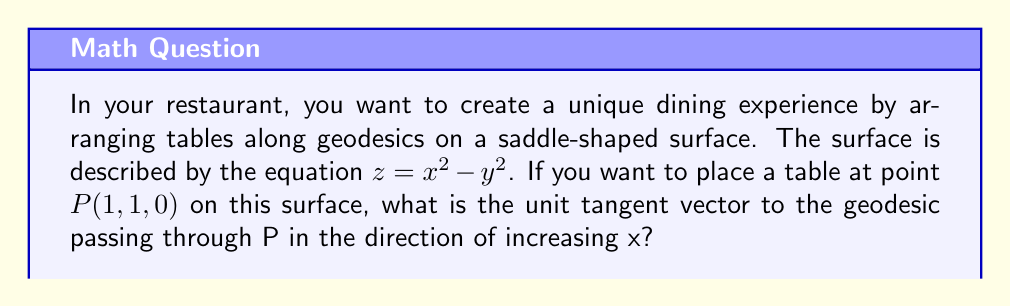Help me with this question. To solve this problem, we'll follow these steps:

1) First, we need to understand that geodesics on a surface follow paths of minimal distance, similar to straight lines in Euclidean geometry.

2) On a saddle surface, the geodesics can be complex curves. To find the tangent vector, we need to use the geodesic equation for this surface.

3) The geodesic equation for a surface $z = f(x,y)$ is given by:

   $$\frac{d^2x}{ds^2} = -\Gamma^x_{xx}\left(\frac{dx}{ds}\right)^2 - 2\Gamma^x_{xy}\frac{dx}{ds}\frac{dy}{ds} - \Gamma^x_{yy}\left(\frac{dy}{ds}\right)^2$$
   $$\frac{d^2y}{ds^2} = -\Gamma^y_{xx}\left(\frac{dx}{ds}\right)^2 - 2\Gamma^y_{xy}\frac{dx}{ds}\frac{dy}{ds} - \Gamma^y_{yy}\left(\frac{dy}{ds}\right)^2$$

   Where $\Gamma^i_{jk}$ are the Christoffel symbols.

4) For our surface $z = x^2 - y^2$, the non-zero Christoffel symbols are:

   $$\Gamma^x_{xx} = \frac{2x}{1+4x^2+4y^2}, \Gamma^x_{xy} = \frac{-2y}{1+4x^2+4y^2}$$
   $$\Gamma^y_{xy} = \frac{2x}{1+4x^2+4y^2}, \Gamma^y_{yy} = \frac{2y}{1+4x^2+4y^2}$$

5) At point $P(1,1,0)$, these values simplify to:

   $$\Gamma^x_{xx} = \Gamma^x_{xy} = \Gamma^y_{xy} = \Gamma^y_{yy} = \frac{1}{5}$$

6) For a geodesic in the direction of increasing x, we can set $\frac{dx}{ds} = 1$ at $P$. Then, from the geodesic equation:

   $$\frac{d^2y}{ds^2} = -2\Gamma^y_{xy}\frac{dx}{ds}\frac{dy}{ds} - \Gamma^y_{yy}\left(\frac{dy}{ds}\right)^2$$

7) At $P$, this becomes:

   $$\frac{d^2y}{ds^2} = -\frac{2}{5}\frac{dy}{ds} - \frac{1}{5}\left(\frac{dy}{ds}\right)^2$$

8) For the initial direction of the geodesic, we're interested in the linear term. So, $\frac{dy}{ds} \approx -\frac{2}{5}$.

9) Therefore, the unit tangent vector to the geodesic at $P$ is approximately:

   $$\vec{v} = \frac{1}{\sqrt{1+(\frac{2}{5})^2}}(1, -\frac{2}{5}, 2)$$

   The last component comes from $\frac{\partial z}{\partial x} = 2x = 2$ at $P$.

10) Normalizing this vector gives our final answer.
Answer: $$\frac{1}{\sqrt{\frac{41}{25}}}(1, -\frac{2}{5}, 2)$$ 